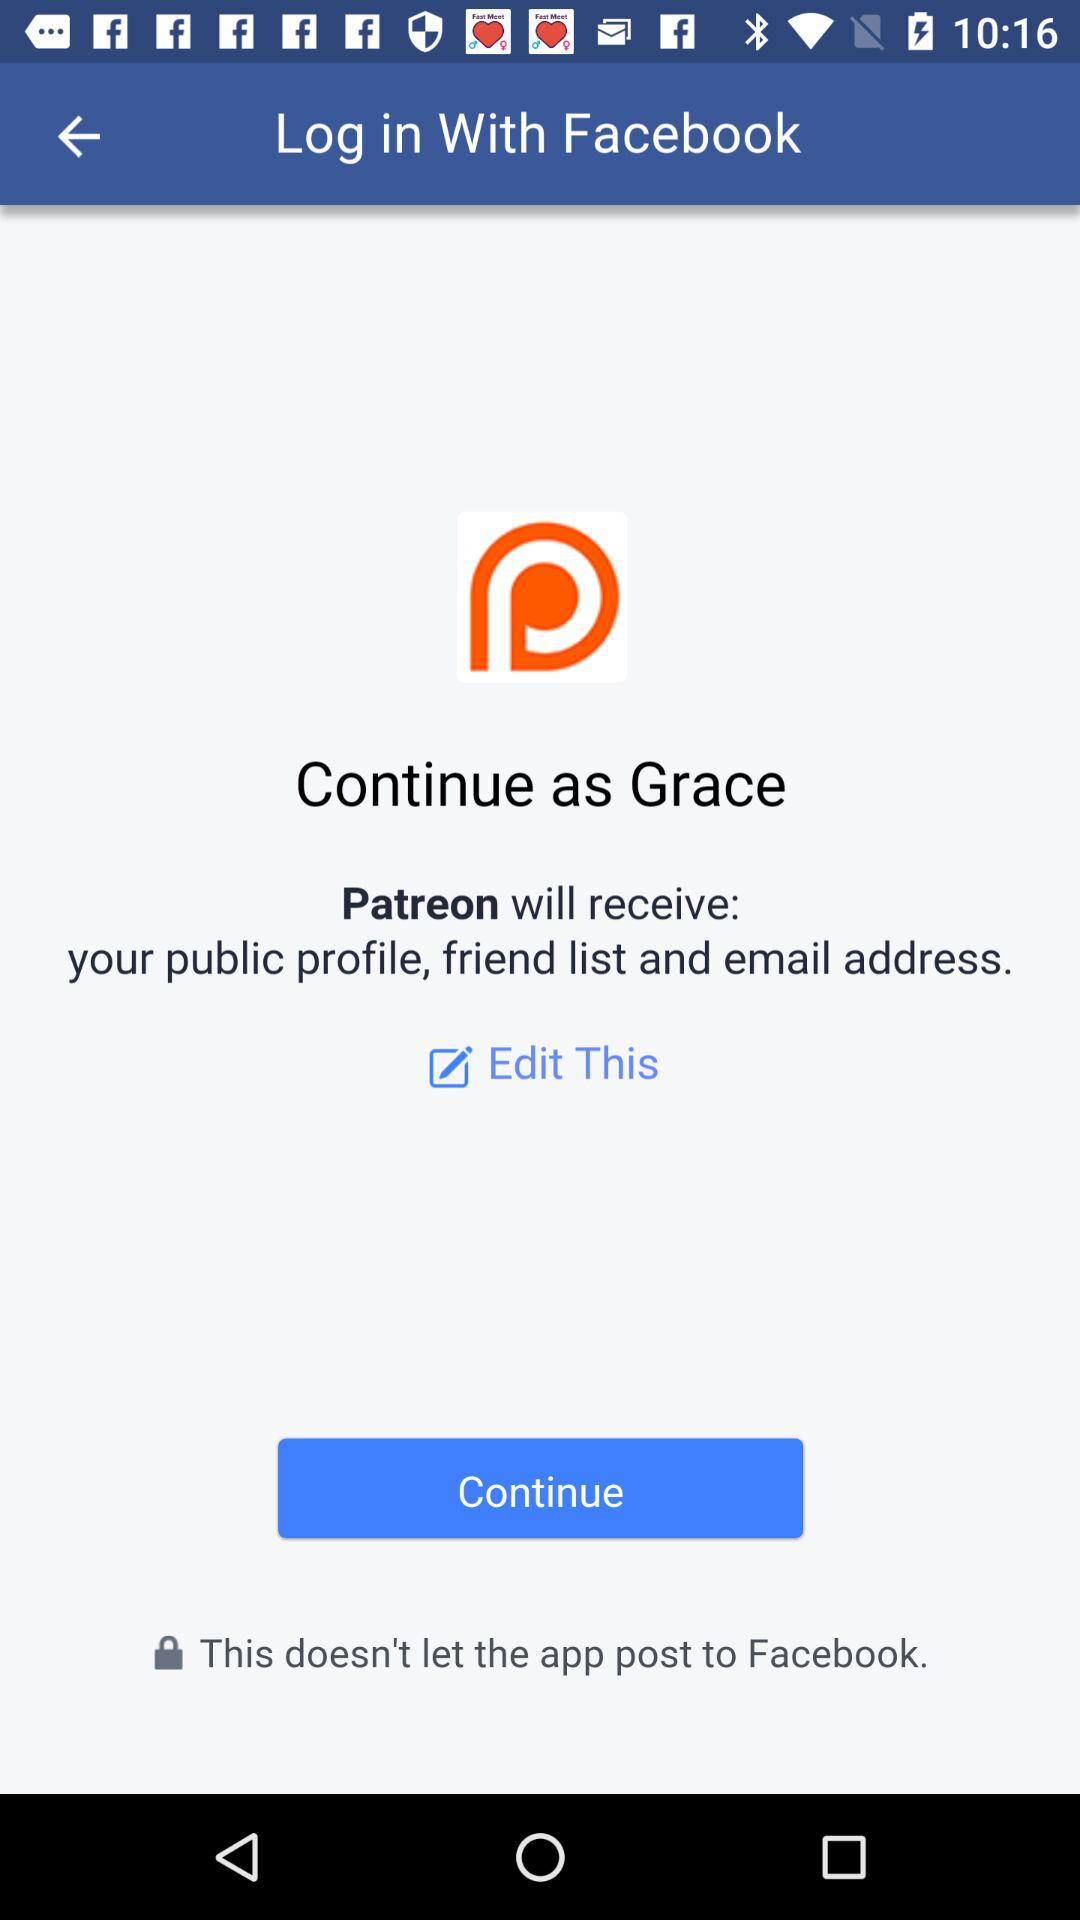What is the name of the user? The name of the user is Grace. 